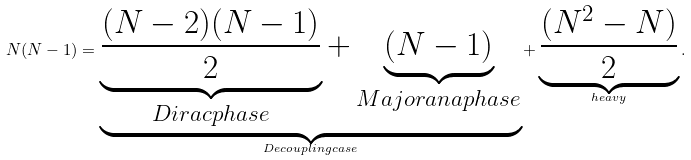Convert formula to latex. <formula><loc_0><loc_0><loc_500><loc_500>N ( N - 1 ) = \underbrace { \underbrace { \frac { ( N - 2 ) ( N - 1 ) } { 2 } } _ { D i r a c p h a s e } + \underbrace { ( N - 1 ) } _ { M a j o r a n a p h a s e } } _ { D e c o u p l i n g c a s e } + \underbrace { \frac { ( N ^ { 2 } - N ) } { 2 } } _ { h e a v y } .</formula> 